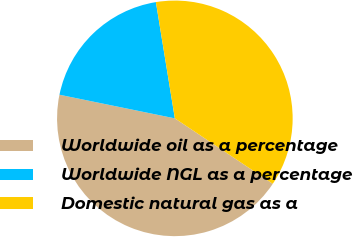<chart> <loc_0><loc_0><loc_500><loc_500><pie_chart><fcel>Worldwide oil as a percentage<fcel>Worldwide NGL as a percentage<fcel>Domestic natural gas as a<nl><fcel>43.84%<fcel>19.21%<fcel>36.95%<nl></chart> 